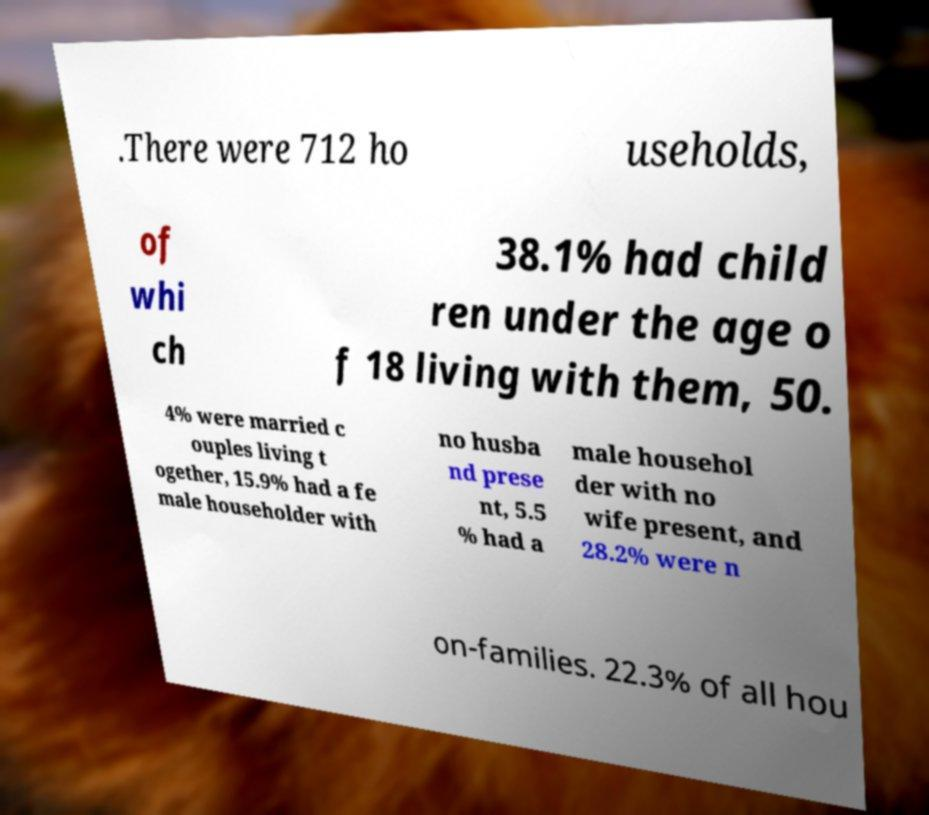Could you assist in decoding the text presented in this image and type it out clearly? .There were 712 ho useholds, of whi ch 38.1% had child ren under the age o f 18 living with them, 50. 4% were married c ouples living t ogether, 15.9% had a fe male householder with no husba nd prese nt, 5.5 % had a male househol der with no wife present, and 28.2% were n on-families. 22.3% of all hou 